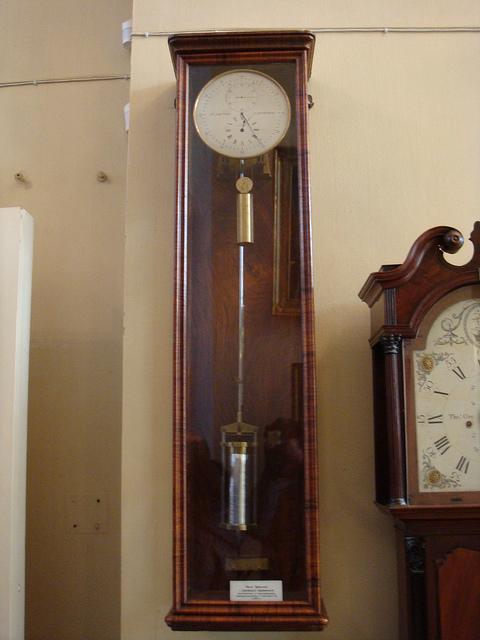Which clock is digital?
Short answer required. Neither. What is leaning on the wall?
Give a very brief answer. Clock. What color is the wall?
Quick response, please. Tan. What time is shown on the clock?
Answer briefly. 6:25. What time is it?
Write a very short answer. 6:25. What kind of clock is shown?
Write a very short answer. Grandfather. What time does the clock say?
Answer briefly. 6:25. Would this be hung in a child's room?
Concise answer only. No. Is this an Aunt clock?
Be succinct. No. How many clocks are there in the picture?
Concise answer only. 2. 